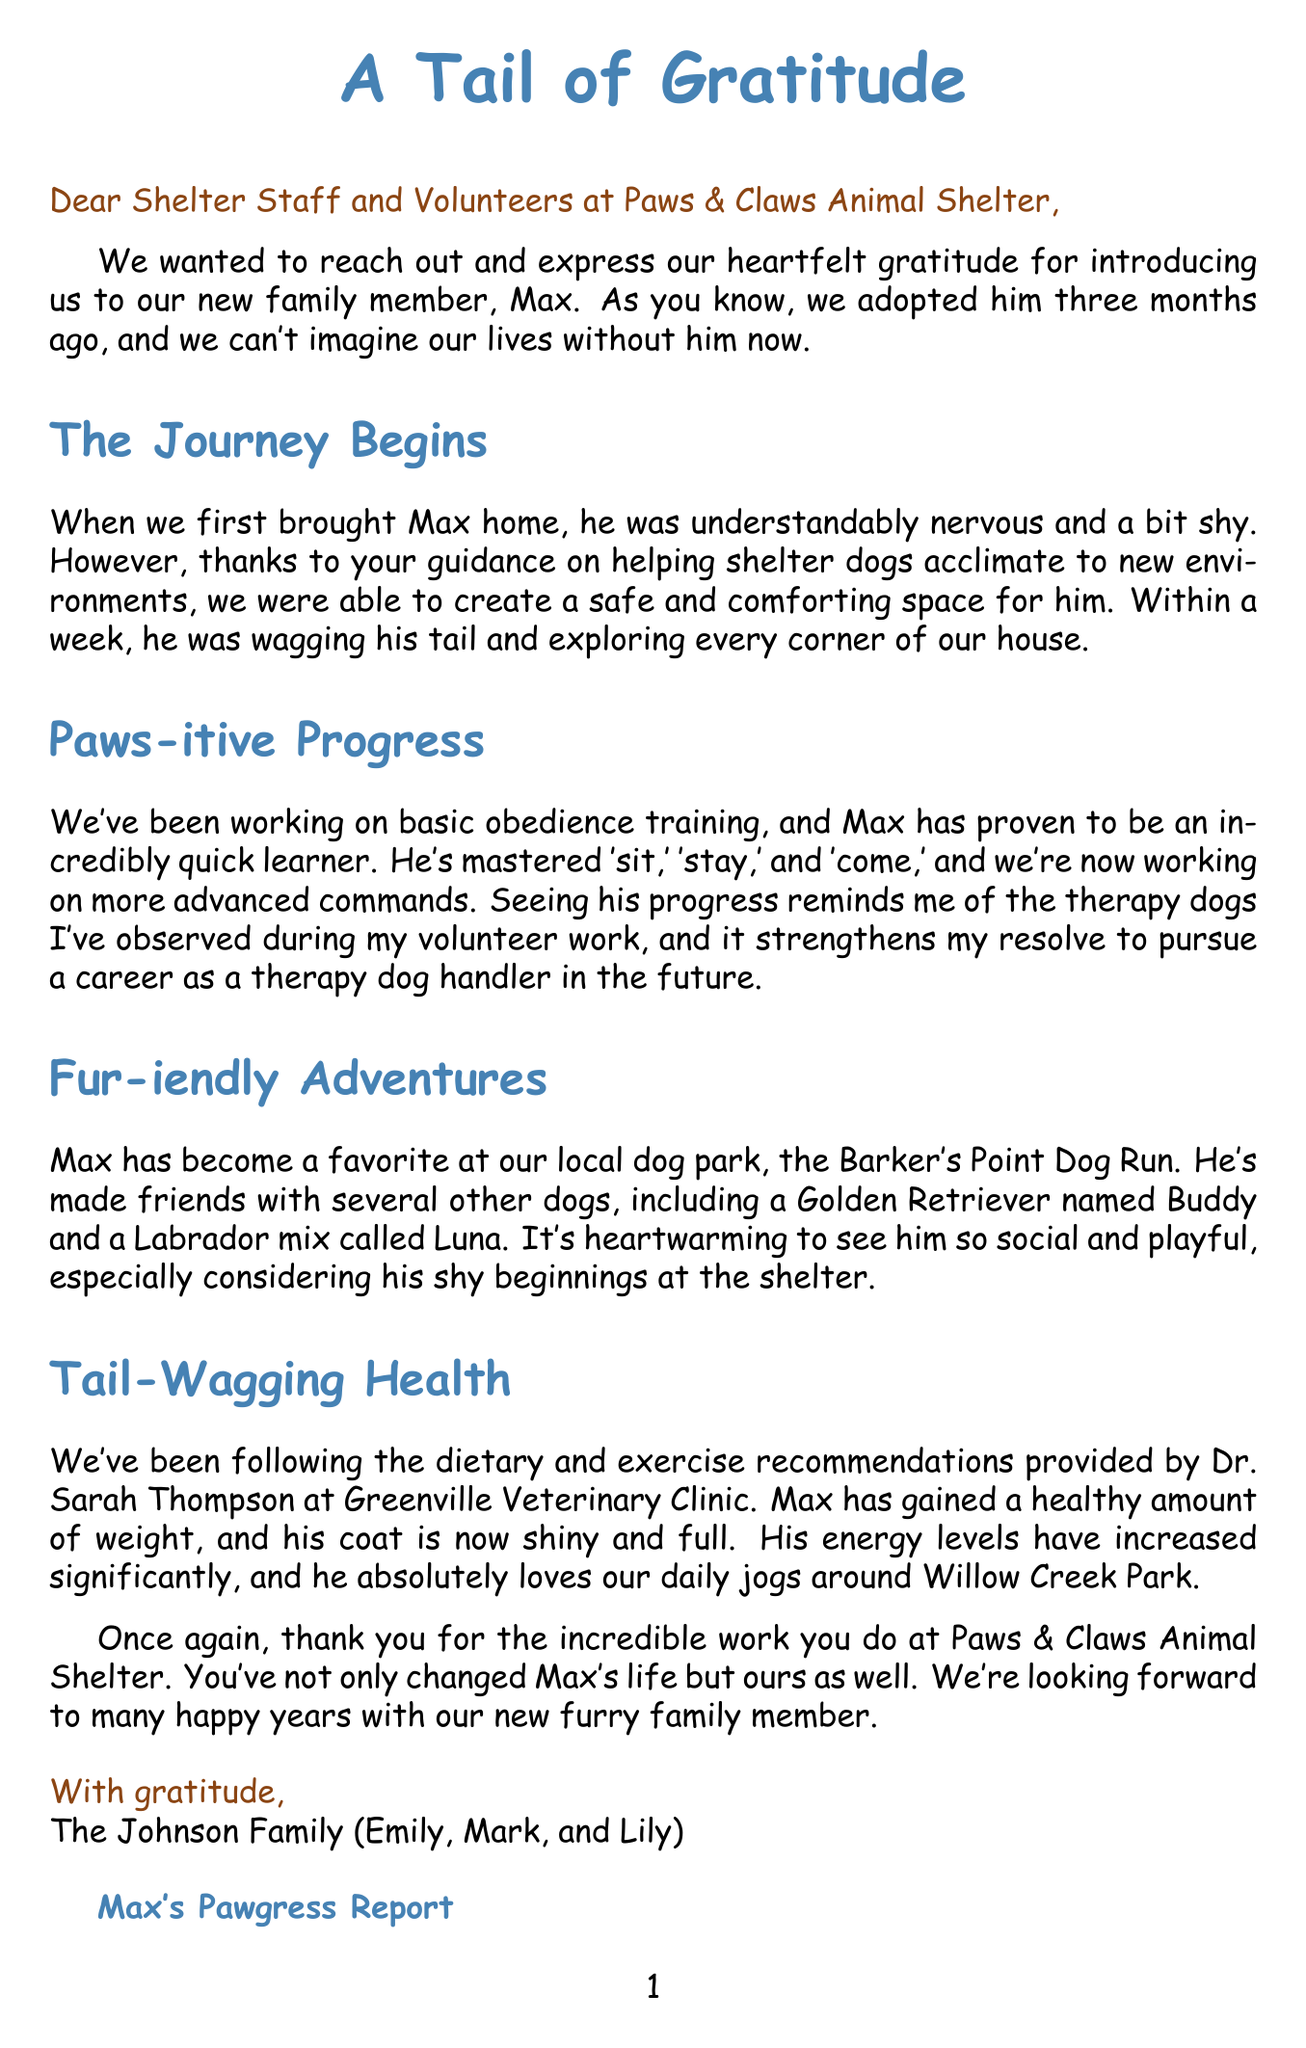What is the name of the dog adopted by the Johnson family? The name of the dog is mentioned as Max in the letter.
Answer: Max How many months ago was Max adopted? The letter states that Max was adopted three months ago.
Answer: three months What is the name of the veterinarian mentioned in the letter? The veterinarian mentioned is Dr. Sarah Thompson at Greenville Veterinary Clinic.
Answer: Dr. Sarah Thompson What command has Max not yet mastered according to the letter? The letter discusses Max mastering 'sit,' 'stay,' and 'come,' but mentions that there are more advanced commands he is currently learning.
Answer: advanced commands What type of toys does the family use to keep Max entertained? The family uses Kong Classic toys and puzzle feeders to keep Max entertained.
Answer: Kong Classic toys What is Max's current healthy weight? The letter states that Max has reached a healthy weight of 65 pounds.
Answer: 65 pounds What has improved significantly in Max due to regular exercise? The letter indicates that Max's muscle tone has improved significantly due to regular exercise.
Answer: muscle tone How does Max greet his family when they return home? It is mentioned that he greets them with enthusiasm.
Answer: with enthusiasm What color is Max's coat now? The letter describes Max's coat as shiny and full.
Answer: shiny and full 